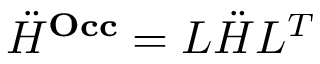Convert formula to latex. <formula><loc_0><loc_0><loc_500><loc_500>\ddot { H } ^ { O c c } = L \ddot { H } L ^ { T }</formula> 